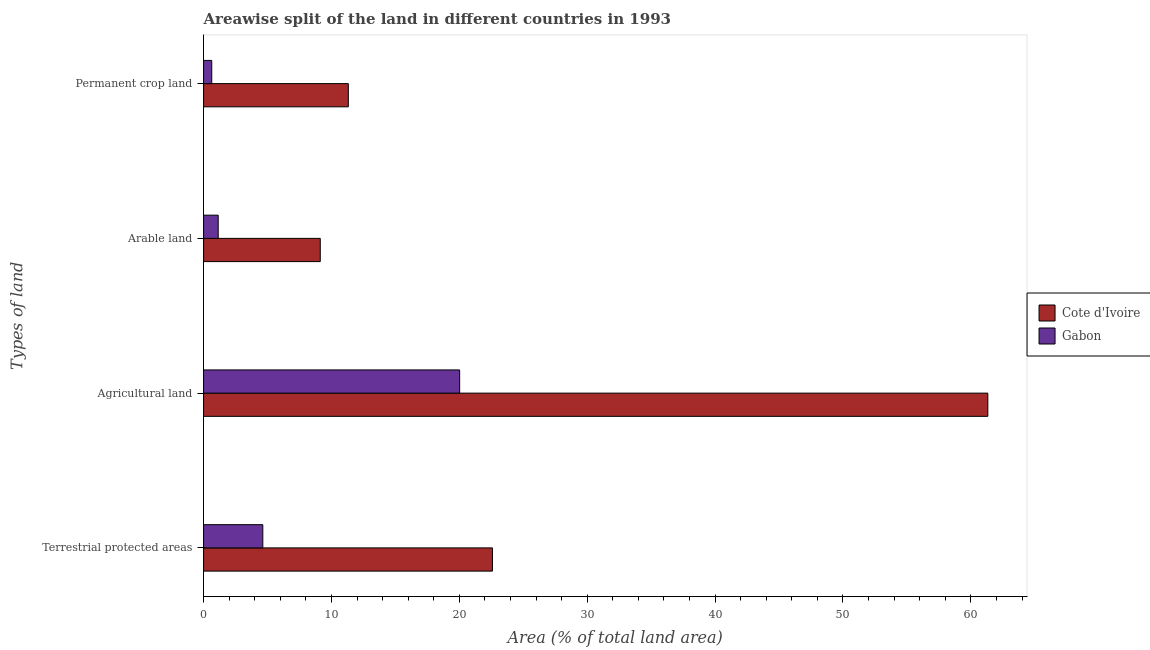How many groups of bars are there?
Ensure brevity in your answer.  4. Are the number of bars per tick equal to the number of legend labels?
Make the answer very short. Yes. How many bars are there on the 1st tick from the top?
Keep it short and to the point. 2. What is the label of the 4th group of bars from the top?
Provide a short and direct response. Terrestrial protected areas. What is the percentage of area under arable land in Gabon?
Offer a very short reply. 1.14. Across all countries, what is the maximum percentage of area under arable land?
Your answer should be compact. 9.13. Across all countries, what is the minimum percentage of land under terrestrial protection?
Ensure brevity in your answer.  4.63. In which country was the percentage of area under agricultural land maximum?
Provide a short and direct response. Cote d'Ivoire. In which country was the percentage of area under permanent crop land minimum?
Provide a succinct answer. Gabon. What is the total percentage of area under agricultural land in the graph?
Make the answer very short. 81.35. What is the difference between the percentage of area under arable land in Cote d'Ivoire and that in Gabon?
Offer a terse response. 7.98. What is the difference between the percentage of area under agricultural land in Cote d'Ivoire and the percentage of area under permanent crop land in Gabon?
Give a very brief answer. 60.69. What is the average percentage of area under arable land per country?
Offer a very short reply. 5.14. What is the difference between the percentage of area under arable land and percentage of land under terrestrial protection in Gabon?
Provide a short and direct response. -3.49. In how many countries, is the percentage of area under arable land greater than 42 %?
Your answer should be very brief. 0. What is the ratio of the percentage of area under agricultural land in Cote d'Ivoire to that in Gabon?
Offer a very short reply. 3.06. What is the difference between the highest and the second highest percentage of area under agricultural land?
Offer a terse response. 41.3. What is the difference between the highest and the lowest percentage of area under arable land?
Keep it short and to the point. 7.98. What does the 2nd bar from the top in Agricultural land represents?
Make the answer very short. Cote d'Ivoire. What does the 2nd bar from the bottom in Terrestrial protected areas represents?
Your response must be concise. Gabon. Is it the case that in every country, the sum of the percentage of land under terrestrial protection and percentage of area under agricultural land is greater than the percentage of area under arable land?
Your response must be concise. Yes. How many bars are there?
Give a very brief answer. 8. How many countries are there in the graph?
Your response must be concise. 2. Are the values on the major ticks of X-axis written in scientific E-notation?
Give a very brief answer. No. Does the graph contain any zero values?
Your answer should be compact. No. Does the graph contain grids?
Keep it short and to the point. No. What is the title of the graph?
Your answer should be very brief. Areawise split of the land in different countries in 1993. What is the label or title of the X-axis?
Your answer should be compact. Area (% of total land area). What is the label or title of the Y-axis?
Keep it short and to the point. Types of land. What is the Area (% of total land area) of Cote d'Ivoire in Terrestrial protected areas?
Offer a terse response. 22.59. What is the Area (% of total land area) in Gabon in Terrestrial protected areas?
Provide a short and direct response. 4.63. What is the Area (% of total land area) in Cote d'Ivoire in Agricultural land?
Offer a terse response. 61.33. What is the Area (% of total land area) of Gabon in Agricultural land?
Offer a terse response. 20.03. What is the Area (% of total land area) of Cote d'Ivoire in Arable land?
Give a very brief answer. 9.13. What is the Area (% of total land area) in Gabon in Arable land?
Make the answer very short. 1.14. What is the Area (% of total land area) in Cote d'Ivoire in Permanent crop land?
Give a very brief answer. 11.32. What is the Area (% of total land area) in Gabon in Permanent crop land?
Give a very brief answer. 0.64. Across all Types of land, what is the maximum Area (% of total land area) in Cote d'Ivoire?
Ensure brevity in your answer.  61.33. Across all Types of land, what is the maximum Area (% of total land area) of Gabon?
Provide a short and direct response. 20.03. Across all Types of land, what is the minimum Area (% of total land area) of Cote d'Ivoire?
Provide a short and direct response. 9.13. Across all Types of land, what is the minimum Area (% of total land area) of Gabon?
Give a very brief answer. 0.64. What is the total Area (% of total land area) of Cote d'Ivoire in the graph?
Your answer should be very brief. 104.36. What is the total Area (% of total land area) in Gabon in the graph?
Offer a terse response. 26.44. What is the difference between the Area (% of total land area) of Cote d'Ivoire in Terrestrial protected areas and that in Agricultural land?
Ensure brevity in your answer.  -38.74. What is the difference between the Area (% of total land area) of Gabon in Terrestrial protected areas and that in Agricultural land?
Your response must be concise. -15.39. What is the difference between the Area (% of total land area) of Cote d'Ivoire in Terrestrial protected areas and that in Arable land?
Ensure brevity in your answer.  13.46. What is the difference between the Area (% of total land area) in Gabon in Terrestrial protected areas and that in Arable land?
Your answer should be compact. 3.49. What is the difference between the Area (% of total land area) in Cote d'Ivoire in Terrestrial protected areas and that in Permanent crop land?
Keep it short and to the point. 11.27. What is the difference between the Area (% of total land area) in Gabon in Terrestrial protected areas and that in Permanent crop land?
Keep it short and to the point. 3.99. What is the difference between the Area (% of total land area) in Cote d'Ivoire in Agricultural land and that in Arable land?
Provide a short and direct response. 52.2. What is the difference between the Area (% of total land area) of Gabon in Agricultural land and that in Arable land?
Your answer should be compact. 18.88. What is the difference between the Area (% of total land area) in Cote d'Ivoire in Agricultural land and that in Permanent crop land?
Provide a succinct answer. 50.01. What is the difference between the Area (% of total land area) of Gabon in Agricultural land and that in Permanent crop land?
Your response must be concise. 19.39. What is the difference between the Area (% of total land area) in Cote d'Ivoire in Arable land and that in Permanent crop land?
Your answer should be very brief. -2.19. What is the difference between the Area (% of total land area) of Gabon in Arable land and that in Permanent crop land?
Provide a succinct answer. 0.5. What is the difference between the Area (% of total land area) of Cote d'Ivoire in Terrestrial protected areas and the Area (% of total land area) of Gabon in Agricultural land?
Offer a very short reply. 2.56. What is the difference between the Area (% of total land area) in Cote d'Ivoire in Terrestrial protected areas and the Area (% of total land area) in Gabon in Arable land?
Your answer should be very brief. 21.44. What is the difference between the Area (% of total land area) of Cote d'Ivoire in Terrestrial protected areas and the Area (% of total land area) of Gabon in Permanent crop land?
Your response must be concise. 21.95. What is the difference between the Area (% of total land area) in Cote d'Ivoire in Agricultural land and the Area (% of total land area) in Gabon in Arable land?
Provide a succinct answer. 60.18. What is the difference between the Area (% of total land area) of Cote d'Ivoire in Agricultural land and the Area (% of total land area) of Gabon in Permanent crop land?
Your response must be concise. 60.69. What is the difference between the Area (% of total land area) in Cote d'Ivoire in Arable land and the Area (% of total land area) in Gabon in Permanent crop land?
Give a very brief answer. 8.49. What is the average Area (% of total land area) in Cote d'Ivoire per Types of land?
Keep it short and to the point. 26.09. What is the average Area (% of total land area) of Gabon per Types of land?
Offer a very short reply. 6.61. What is the difference between the Area (% of total land area) in Cote d'Ivoire and Area (% of total land area) in Gabon in Terrestrial protected areas?
Offer a terse response. 17.96. What is the difference between the Area (% of total land area) in Cote d'Ivoire and Area (% of total land area) in Gabon in Agricultural land?
Make the answer very short. 41.3. What is the difference between the Area (% of total land area) in Cote d'Ivoire and Area (% of total land area) in Gabon in Arable land?
Your response must be concise. 7.98. What is the difference between the Area (% of total land area) in Cote d'Ivoire and Area (% of total land area) in Gabon in Permanent crop land?
Offer a terse response. 10.68. What is the ratio of the Area (% of total land area) in Cote d'Ivoire in Terrestrial protected areas to that in Agricultural land?
Your response must be concise. 0.37. What is the ratio of the Area (% of total land area) in Gabon in Terrestrial protected areas to that in Agricultural land?
Keep it short and to the point. 0.23. What is the ratio of the Area (% of total land area) in Cote d'Ivoire in Terrestrial protected areas to that in Arable land?
Your answer should be compact. 2.48. What is the ratio of the Area (% of total land area) in Gabon in Terrestrial protected areas to that in Arable land?
Your response must be concise. 4.05. What is the ratio of the Area (% of total land area) in Cote d'Ivoire in Terrestrial protected areas to that in Permanent crop land?
Keep it short and to the point. 2. What is the ratio of the Area (% of total land area) of Gabon in Terrestrial protected areas to that in Permanent crop land?
Keep it short and to the point. 7.23. What is the ratio of the Area (% of total land area) in Cote d'Ivoire in Agricultural land to that in Arable land?
Your answer should be compact. 6.72. What is the ratio of the Area (% of total land area) of Gabon in Agricultural land to that in Arable land?
Keep it short and to the point. 17.49. What is the ratio of the Area (% of total land area) in Cote d'Ivoire in Agricultural land to that in Permanent crop land?
Offer a very short reply. 5.42. What is the ratio of the Area (% of total land area) in Gabon in Agricultural land to that in Permanent crop land?
Your answer should be compact. 31.27. What is the ratio of the Area (% of total land area) in Cote d'Ivoire in Arable land to that in Permanent crop land?
Provide a short and direct response. 0.81. What is the ratio of the Area (% of total land area) of Gabon in Arable land to that in Permanent crop land?
Offer a very short reply. 1.79. What is the difference between the highest and the second highest Area (% of total land area) in Cote d'Ivoire?
Make the answer very short. 38.74. What is the difference between the highest and the second highest Area (% of total land area) in Gabon?
Offer a very short reply. 15.39. What is the difference between the highest and the lowest Area (% of total land area) of Cote d'Ivoire?
Make the answer very short. 52.2. What is the difference between the highest and the lowest Area (% of total land area) in Gabon?
Give a very brief answer. 19.39. 